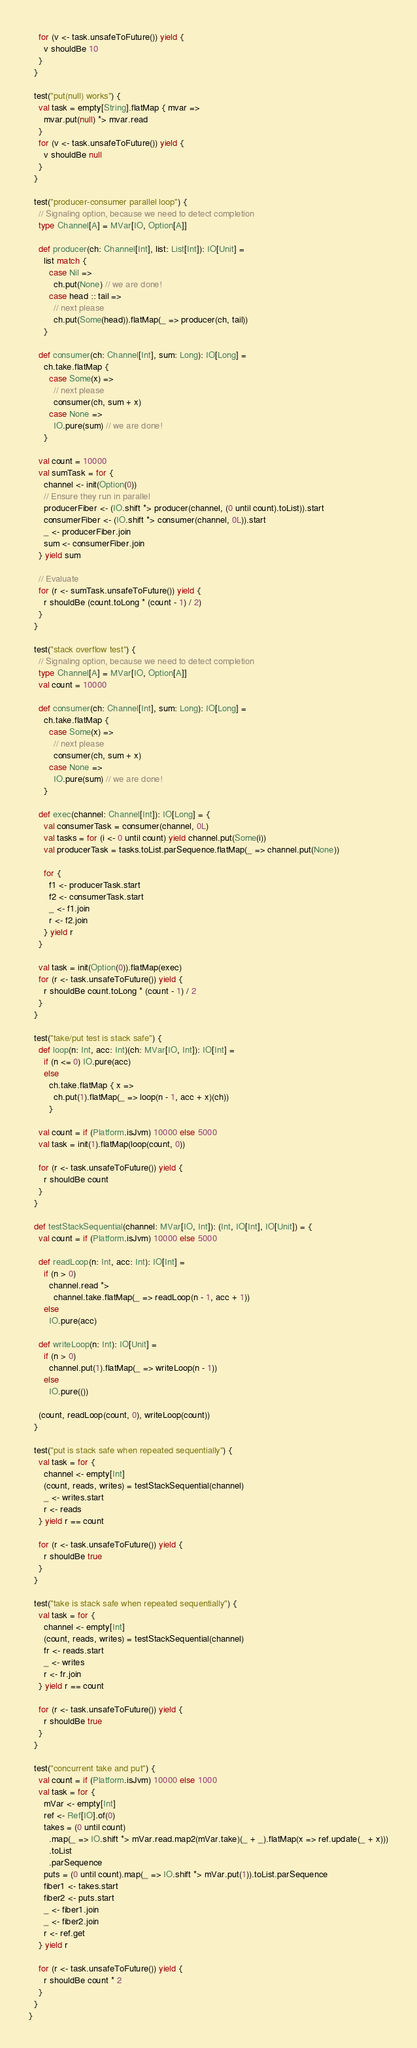Convert code to text. <code><loc_0><loc_0><loc_500><loc_500><_Scala_>    for (v <- task.unsafeToFuture()) yield {
      v shouldBe 10
    }
  }

  test("put(null) works") {
    val task = empty[String].flatMap { mvar =>
      mvar.put(null) *> mvar.read
    }
    for (v <- task.unsafeToFuture()) yield {
      v shouldBe null
    }
  }

  test("producer-consumer parallel loop") {
    // Signaling option, because we need to detect completion
    type Channel[A] = MVar[IO, Option[A]]

    def producer(ch: Channel[Int], list: List[Int]): IO[Unit] =
      list match {
        case Nil =>
          ch.put(None) // we are done!
        case head :: tail =>
          // next please
          ch.put(Some(head)).flatMap(_ => producer(ch, tail))
      }

    def consumer(ch: Channel[Int], sum: Long): IO[Long] =
      ch.take.flatMap {
        case Some(x) =>
          // next please
          consumer(ch, sum + x)
        case None =>
          IO.pure(sum) // we are done!
      }

    val count = 10000
    val sumTask = for {
      channel <- init(Option(0))
      // Ensure they run in parallel
      producerFiber <- (IO.shift *> producer(channel, (0 until count).toList)).start
      consumerFiber <- (IO.shift *> consumer(channel, 0L)).start
      _ <- producerFiber.join
      sum <- consumerFiber.join
    } yield sum

    // Evaluate
    for (r <- sumTask.unsafeToFuture()) yield {
      r shouldBe (count.toLong * (count - 1) / 2)
    }
  }

  test("stack overflow test") {
    // Signaling option, because we need to detect completion
    type Channel[A] = MVar[IO, Option[A]]
    val count = 10000

    def consumer(ch: Channel[Int], sum: Long): IO[Long] =
      ch.take.flatMap {
        case Some(x) =>
          // next please
          consumer(ch, sum + x)
        case None =>
          IO.pure(sum) // we are done!
      }

    def exec(channel: Channel[Int]): IO[Long] = {
      val consumerTask = consumer(channel, 0L)
      val tasks = for (i <- 0 until count) yield channel.put(Some(i))
      val producerTask = tasks.toList.parSequence.flatMap(_ => channel.put(None))

      for {
        f1 <- producerTask.start
        f2 <- consumerTask.start
        _ <- f1.join
        r <- f2.join
      } yield r
    }

    val task = init(Option(0)).flatMap(exec)
    for (r <- task.unsafeToFuture()) yield {
      r shouldBe count.toLong * (count - 1) / 2
    }
  }

  test("take/put test is stack safe") {
    def loop(n: Int, acc: Int)(ch: MVar[IO, Int]): IO[Int] =
      if (n <= 0) IO.pure(acc)
      else
        ch.take.flatMap { x =>
          ch.put(1).flatMap(_ => loop(n - 1, acc + x)(ch))
        }

    val count = if (Platform.isJvm) 10000 else 5000
    val task = init(1).flatMap(loop(count, 0))

    for (r <- task.unsafeToFuture()) yield {
      r shouldBe count
    }
  }

  def testStackSequential(channel: MVar[IO, Int]): (Int, IO[Int], IO[Unit]) = {
    val count = if (Platform.isJvm) 10000 else 5000

    def readLoop(n: Int, acc: Int): IO[Int] =
      if (n > 0)
        channel.read *>
          channel.take.flatMap(_ => readLoop(n - 1, acc + 1))
      else
        IO.pure(acc)

    def writeLoop(n: Int): IO[Unit] =
      if (n > 0)
        channel.put(1).flatMap(_ => writeLoop(n - 1))
      else
        IO.pure(())

    (count, readLoop(count, 0), writeLoop(count))
  }

  test("put is stack safe when repeated sequentially") {
    val task = for {
      channel <- empty[Int]
      (count, reads, writes) = testStackSequential(channel)
      _ <- writes.start
      r <- reads
    } yield r == count

    for (r <- task.unsafeToFuture()) yield {
      r shouldBe true
    }
  }

  test("take is stack safe when repeated sequentially") {
    val task = for {
      channel <- empty[Int]
      (count, reads, writes) = testStackSequential(channel)
      fr <- reads.start
      _ <- writes
      r <- fr.join
    } yield r == count

    for (r <- task.unsafeToFuture()) yield {
      r shouldBe true
    }
  }

  test("concurrent take and put") {
    val count = if (Platform.isJvm) 10000 else 1000
    val task = for {
      mVar <- empty[Int]
      ref <- Ref[IO].of(0)
      takes = (0 until count)
        .map(_ => IO.shift *> mVar.read.map2(mVar.take)(_ + _).flatMap(x => ref.update(_ + x)))
        .toList
        .parSequence
      puts = (0 until count).map(_ => IO.shift *> mVar.put(1)).toList.parSequence
      fiber1 <- takes.start
      fiber2 <- puts.start
      _ <- fiber1.join
      _ <- fiber2.join
      r <- ref.get
    } yield r

    for (r <- task.unsafeToFuture()) yield {
      r shouldBe count * 2
    }
  }
}
</code> 